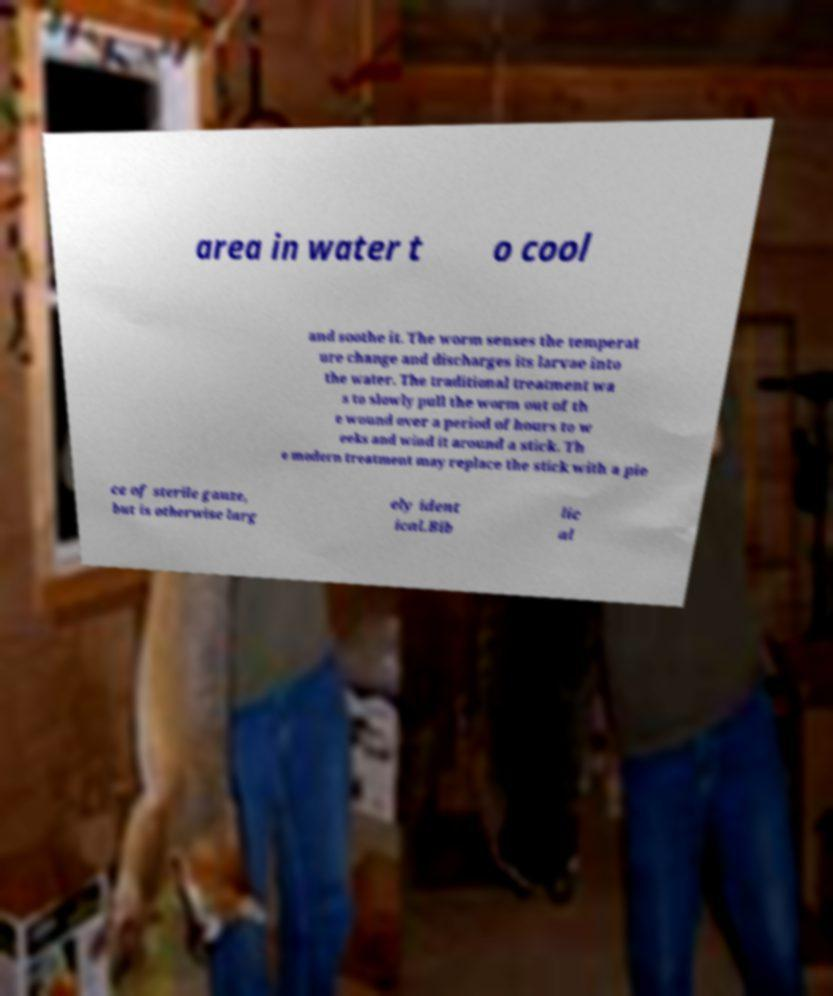There's text embedded in this image that I need extracted. Can you transcribe it verbatim? area in water t o cool and soothe it. The worm senses the temperat ure change and discharges its larvae into the water. The traditional treatment wa s to slowly pull the worm out of th e wound over a period of hours to w eeks and wind it around a stick. Th e modern treatment may replace the stick with a pie ce of sterile gauze, but is otherwise larg ely ident ical.Bib lic al 